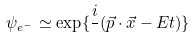<formula> <loc_0><loc_0><loc_500><loc_500>\psi _ { e ^ { - } } \simeq \exp \{ \frac { i } { } ( \vec { p } \cdot \vec { x } - E t ) \}</formula> 